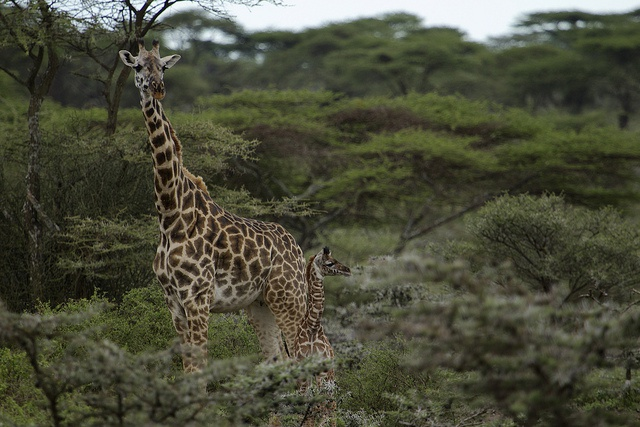Describe the objects in this image and their specific colors. I can see giraffe in teal, gray, and black tones and giraffe in teal, gray, and black tones in this image. 